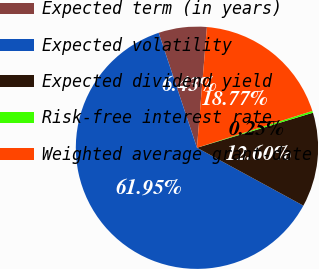<chart> <loc_0><loc_0><loc_500><loc_500><pie_chart><fcel>Expected term (in years)<fcel>Expected volatility<fcel>Expected dividend yield<fcel>Risk-free interest rate<fcel>Weighted average grant-date<nl><fcel>6.43%<fcel>61.95%<fcel>12.6%<fcel>0.25%<fcel>18.77%<nl></chart> 